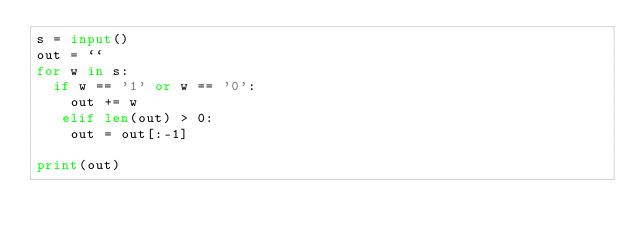Convert code to text. <code><loc_0><loc_0><loc_500><loc_500><_Python_>s = input()
out = ``
for w in s:
  if w == '1' or w == '0':
    out += w
   elif len(out) > 0:
    out = out[:-1]
    
print(out)
   </code> 